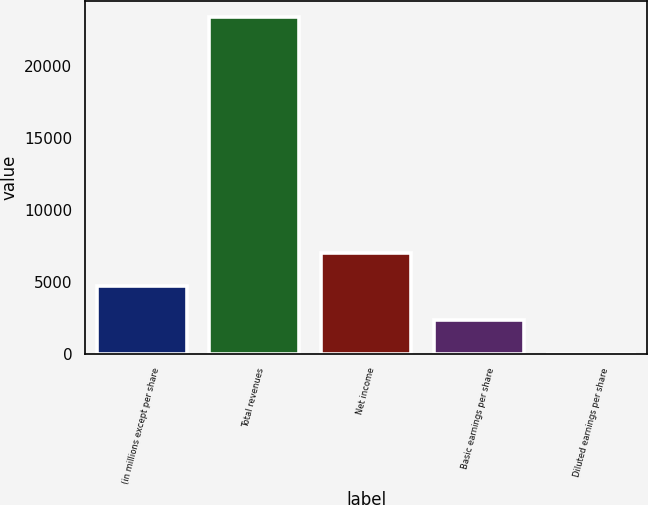Convert chart. <chart><loc_0><loc_0><loc_500><loc_500><bar_chart><fcel>(in millions except per share<fcel>Total revenues<fcel>Net income<fcel>Basic earnings per share<fcel>Diluted earnings per share<nl><fcel>4675.07<fcel>23371<fcel>7012.06<fcel>2338.08<fcel>1.09<nl></chart> 